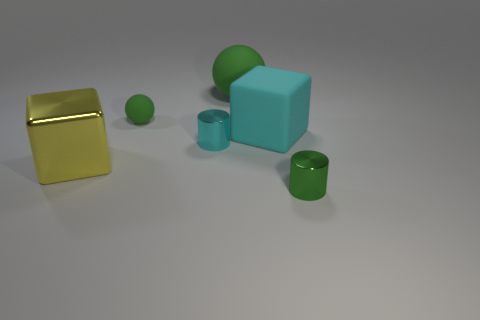Is the number of large matte cubes that are on the left side of the yellow metallic object greater than the number of big yellow objects?
Provide a succinct answer. No. There is a big green rubber thing; what number of tiny matte balls are behind it?
Make the answer very short. 0. What is the shape of the tiny matte object that is the same color as the big matte ball?
Provide a short and direct response. Sphere. Is there a small matte sphere behind the tiny cylinder that is in front of the big thing left of the large green matte object?
Give a very brief answer. Yes. Is the size of the green metallic thing the same as the yellow thing?
Make the answer very short. No. Are there an equal number of spheres that are behind the big green ball and cyan shiny cylinders that are in front of the cyan cylinder?
Offer a very short reply. Yes. There is a big cyan thing behind the tiny cyan metal thing; what is its shape?
Your answer should be compact. Cube. The green rubber thing that is the same size as the green metallic cylinder is what shape?
Your answer should be compact. Sphere. What color is the thing on the left side of the tiny green thing to the left of the shiny cylinder that is right of the cyan shiny cylinder?
Keep it short and to the point. Yellow. Does the large yellow thing have the same shape as the small cyan metal object?
Make the answer very short. No. 